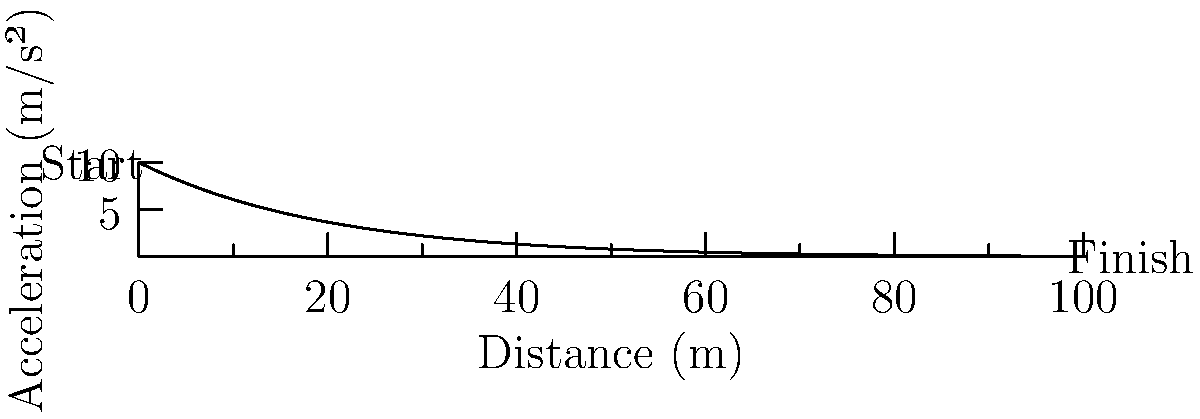As a sprinter aiming to break the world record, you're analyzing acceleration patterns during a 100m sprint. The graph shows the acceleration of a top sprinter throughout the race. At what distance from the starting line does the sprinter's acceleration drop to approximately 5 m/s²? To solve this problem, we need to follow these steps:

1) The acceleration curve is given by the equation $a = 10e^{-x/20}$, where $a$ is the acceleration in m/s² and $x$ is the distance in meters.

2) We need to find $x$ when $a = 5$ m/s².

3) Let's substitute these values into the equation:
   
   $5 = 10e^{-x/20}$

4) Divide both sides by 10:
   
   $0.5 = e^{-x/20}$

5) Take the natural logarithm of both sides:
   
   $\ln(0.5) = -x/20$

6) Multiply both sides by -20:
   
   $-20\ln(0.5) = x$

7) Calculate the value:
   
   $x = -20 * (-0.693) \approx 13.86$ meters

Therefore, the sprinter's acceleration drops to approximately 5 m/s² at about 13.86 meters from the starting line.
Answer: 13.86 meters 